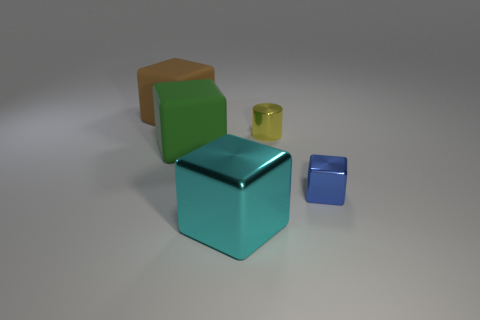Is the number of rubber objects to the left of the big green rubber thing greater than the number of big yellow cylinders?
Offer a terse response. Yes. How many small blue objects are the same shape as the brown thing?
Ensure brevity in your answer.  1. The object that is made of the same material as the large green block is what size?
Your response must be concise. Large. There is a object that is behind the big green thing and to the right of the green rubber object; what color is it?
Ensure brevity in your answer.  Yellow. What number of gray metallic things have the same size as the green matte block?
Your answer should be compact. 0. There is a metal object that is behind the cyan metal block and in front of the metal cylinder; how big is it?
Your response must be concise. Small. How many objects are left of the shiny block behind the large thing in front of the green matte cube?
Provide a succinct answer. 4. The other metallic object that is the same size as the blue metal thing is what color?
Keep it short and to the point. Yellow. The large rubber thing on the right side of the matte thing that is behind the matte thing to the right of the big brown cube is what shape?
Provide a succinct answer. Cube. What number of large brown blocks are behind the metallic block to the left of the yellow cylinder?
Give a very brief answer. 1. 